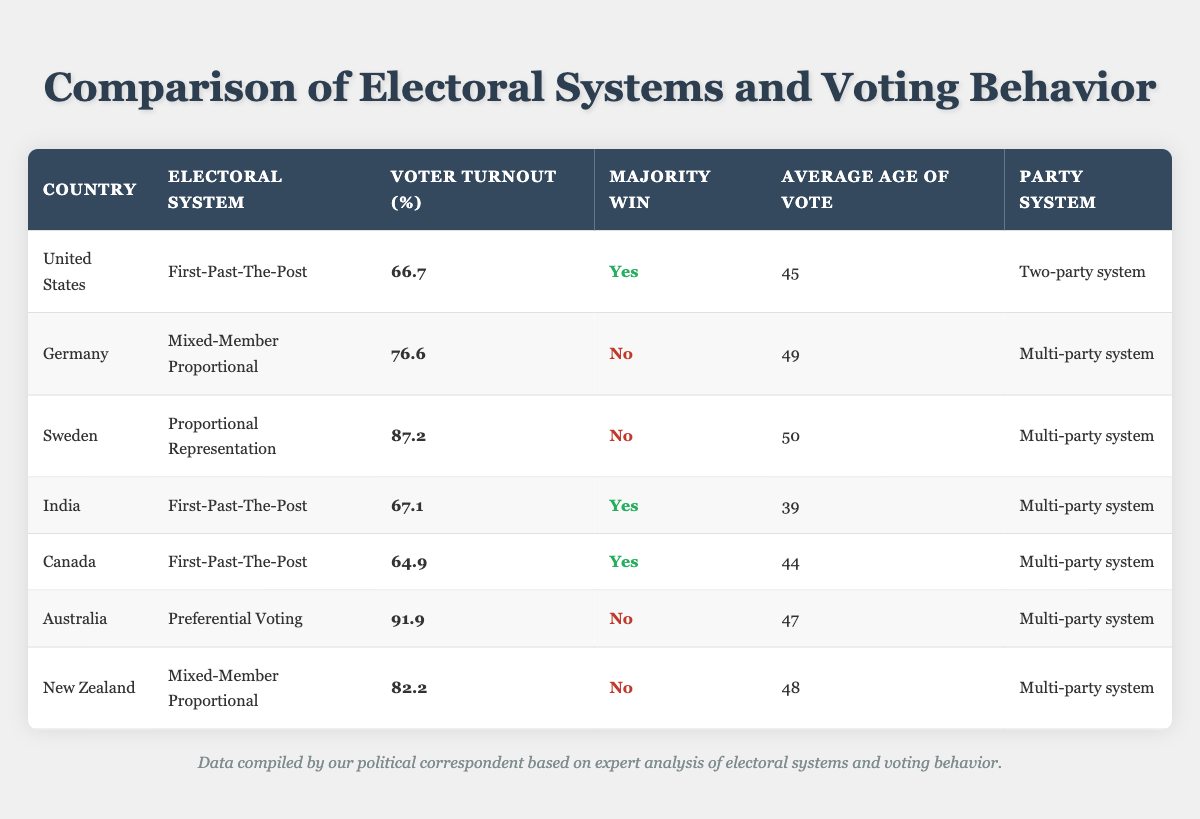What is the voter turnout in Australia? The table shows that the voter turnout in Australia is listed as 91.9%.
Answer: 91.9 How many countries have a multi-party system? By reviewing the table, we see that Germany, Sweden, India, Canada, Australia, and New Zealand all have a multi-party system. That counts for a total of six countries.
Answer: 6 Is majority win achieved in Sweden? The table indicates that Sweden does not achieve majority wins, as marked in the "Majority Win" column.
Answer: No What is the average voter turnout of countries using the First-Past-The-Post system? The countries using this system are the United States (66.7), India (67.1), and Canada (64.9). The average is calculated as (66.7 + 67.1 + 64.9) / 3 = 66.23.
Answer: 66.23 Which country has the highest voter turnout? By inspecting the table, Australia has the highest voter turnout at 91.9%, which is greater than all other countries listed.
Answer: Australia What age group tends to vote more in Sweden? The table states that the average age of voters in Sweden is 50 years old, indicating that individuals around this age are more likely to participate in elections.
Answer: 50 How does the voter turnout in Germany compare to that in Canada? The voter turnout in Germany is 76.6%, while Canada’s is 64.9%. Comparing these figures, Germany's turnout is higher by 11.7%.
Answer: Germany's turnout is higher Is the average voter age in India less than that of New Zealand? The average age of voters in India is 39, while in New Zealand, it is 48. Since 39 is less than 48, the answer is yes.
Answer: Yes What percentage of countries listed have majority win systems? From the table, the countries with majority win systems are the United States, India, and Canada. There are seven countries total, meaning 3 out of 7 have majority win systems, which is approximately 42.86%.
Answer: 42.86% 